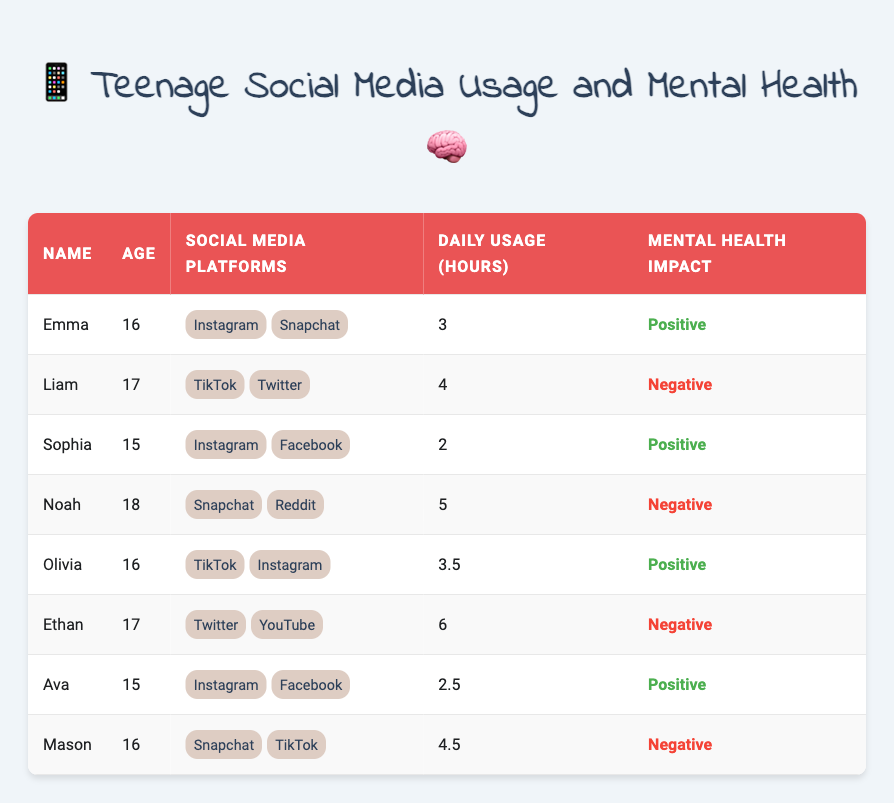What is the name of the teenager with the highest daily social media usage? Looking at the "Daily Usage (hours)" column, Ethan has the highest daily usage at 6 hours.
Answer: Ethan How many teenagers reported a positive impact on their mental health? By scanning the "Mental Health Impact" column, Emma, Sophia, Olivia, and Ava all reported a positive impact, totaling 4 teenagers.
Answer: 4 What is the average daily social media usage for teenagers who reported a negative impact on mental health? The teenagers with a negative impact are Liam, Noah, Ethan, and Mason, with usage hours of 4, 5, 6, and 4.5. The average is (4 + 5 + 6 + 4.5) / 4 = 19.5 / 4 = 4.875 hours.
Answer: 4.875 hours Is there a teenager who uses social media for more than 5 hours and has a positive impact on their mental health? Noah uses 5 hours but has a negative impact, while Ethan uses 6 hours with a negative impact as well. Therefore, no teenager fits the criteria.
Answer: No Which social media platforms are most commonly used among teenagers with a positive impact on mental health? The teenagers with a positive impact are Emma, Sophia, Olivia, and Ava. The platforms used include Instagram (3 occurrences) and Facebook (2 occurrences). Therefore, Instagram is the most common platform.
Answer: Instagram How many teenagers aged 15 reported a positive impact on their mental health? Examining the ages and mental health impact, both Sophia and Ava are aged 15 and reported a positive impact, totaling 2 teenagers.
Answer: 2 What is the total number of hours for which teenagers reported a negative impact on mental health? Liam with 4 hours, Noah with 5 hours, Ethan with 6 hours, and Mason with 4.5 hours gives us a total of 4 + 5 + 6 + 4.5 = 19.5 hours.
Answer: 19.5 hours Are there more teenagers who use Instagram compared to those who use TikTok? The teenagers using Instagram are Emma, Sophia, Olivia, and Ava (4 total), whereas those using TikTok are Liam, Olivia, and Mason (3 total). Therefore, there are more Instagram users.
Answer: Yes 